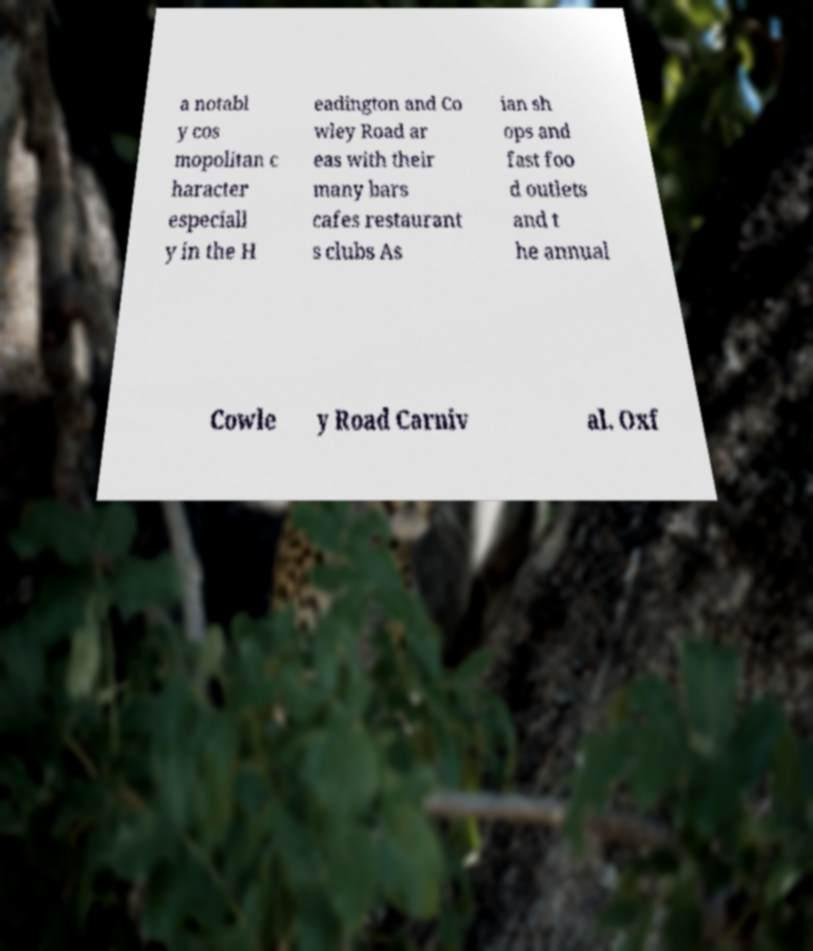There's text embedded in this image that I need extracted. Can you transcribe it verbatim? a notabl y cos mopolitan c haracter especiall y in the H eadington and Co wley Road ar eas with their many bars cafes restaurant s clubs As ian sh ops and fast foo d outlets and t he annual Cowle y Road Carniv al. Oxf 